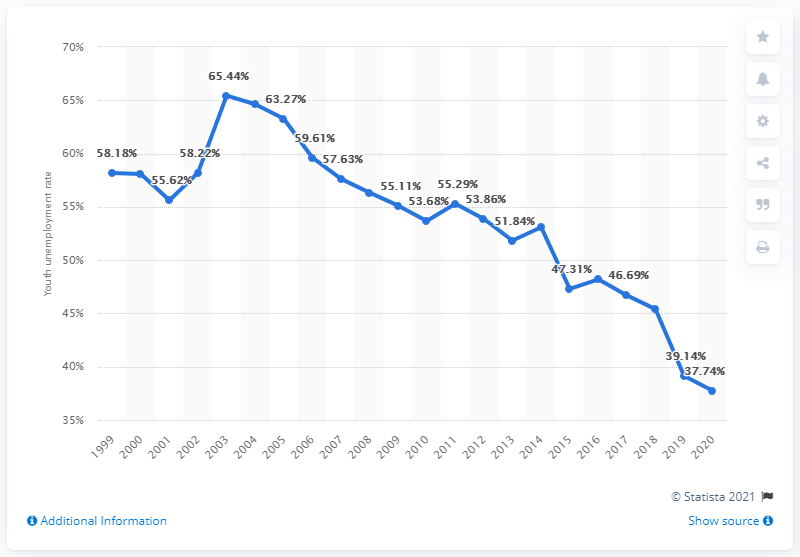Point out several critical features in this image. In 2020, the youth unemployment rate in North Macedonia was 37.74%. 